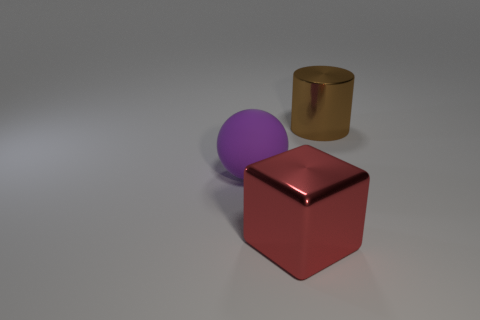Add 2 brown shiny cylinders. How many objects exist? 5 Subtract all blue blocks. Subtract all cyan balls. How many blocks are left? 1 Subtract 0 green cylinders. How many objects are left? 3 Subtract all cylinders. How many objects are left? 2 Subtract all tiny red blocks. Subtract all brown metal things. How many objects are left? 2 Add 3 purple balls. How many purple balls are left? 4 Add 2 large metallic cylinders. How many large metallic cylinders exist? 3 